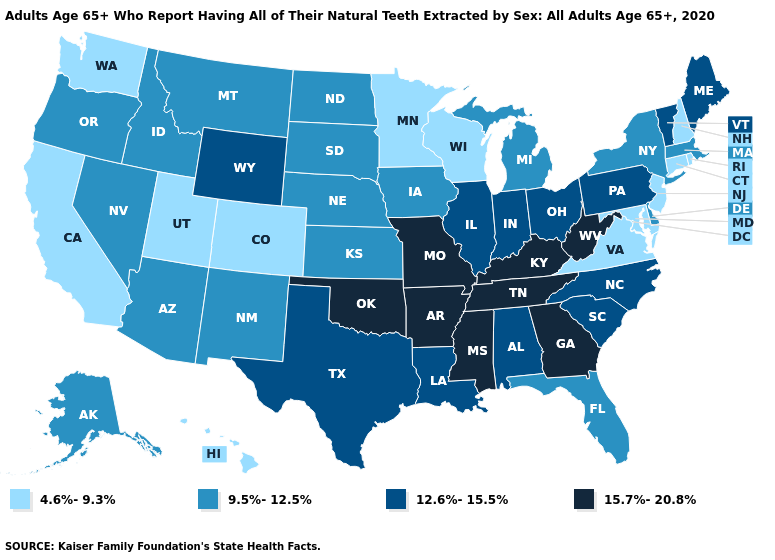Name the states that have a value in the range 12.6%-15.5%?
Be succinct. Alabama, Illinois, Indiana, Louisiana, Maine, North Carolina, Ohio, Pennsylvania, South Carolina, Texas, Vermont, Wyoming. Name the states that have a value in the range 4.6%-9.3%?
Answer briefly. California, Colorado, Connecticut, Hawaii, Maryland, Minnesota, New Hampshire, New Jersey, Rhode Island, Utah, Virginia, Washington, Wisconsin. Does Arizona have the highest value in the USA?
Be succinct. No. Does Arkansas have the same value as Oregon?
Short answer required. No. Does the map have missing data?
Concise answer only. No. Name the states that have a value in the range 4.6%-9.3%?
Keep it brief. California, Colorado, Connecticut, Hawaii, Maryland, Minnesota, New Hampshire, New Jersey, Rhode Island, Utah, Virginia, Washington, Wisconsin. Name the states that have a value in the range 4.6%-9.3%?
Give a very brief answer. California, Colorado, Connecticut, Hawaii, Maryland, Minnesota, New Hampshire, New Jersey, Rhode Island, Utah, Virginia, Washington, Wisconsin. What is the highest value in states that border Vermont?
Short answer required. 9.5%-12.5%. Does the first symbol in the legend represent the smallest category?
Keep it brief. Yes. Does the map have missing data?
Concise answer only. No. What is the value of North Dakota?
Quick response, please. 9.5%-12.5%. What is the highest value in the USA?
Write a very short answer. 15.7%-20.8%. What is the highest value in the USA?
Write a very short answer. 15.7%-20.8%. What is the value of Alaska?
Concise answer only. 9.5%-12.5%. Among the states that border Utah , which have the lowest value?
Keep it brief. Colorado. 